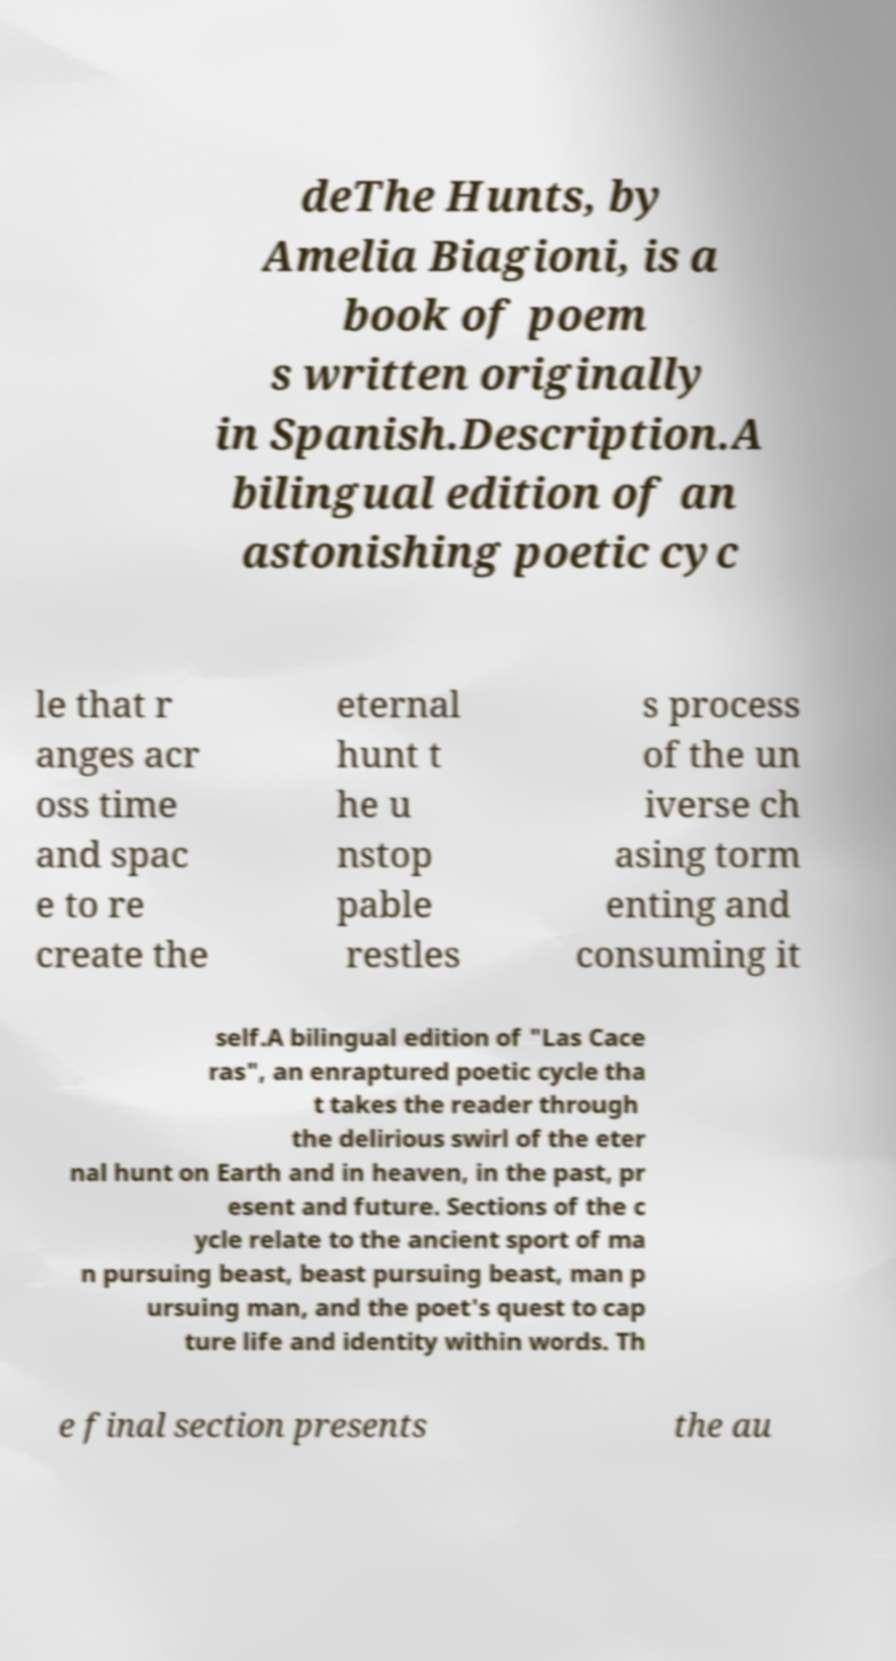I need the written content from this picture converted into text. Can you do that? deThe Hunts, by Amelia Biagioni, is a book of poem s written originally in Spanish.Description.A bilingual edition of an astonishing poetic cyc le that r anges acr oss time and spac e to re create the eternal hunt t he u nstop pable restles s process of the un iverse ch asing torm enting and consuming it self.A bilingual edition of "Las Cace ras", an enraptured poetic cycle tha t takes the reader through the delirious swirl of the eter nal hunt on Earth and in heaven, in the past, pr esent and future. Sections of the c ycle relate to the ancient sport of ma n pursuing beast, beast pursuing beast, man p ursuing man, and the poet's quest to cap ture life and identity within words. Th e final section presents the au 